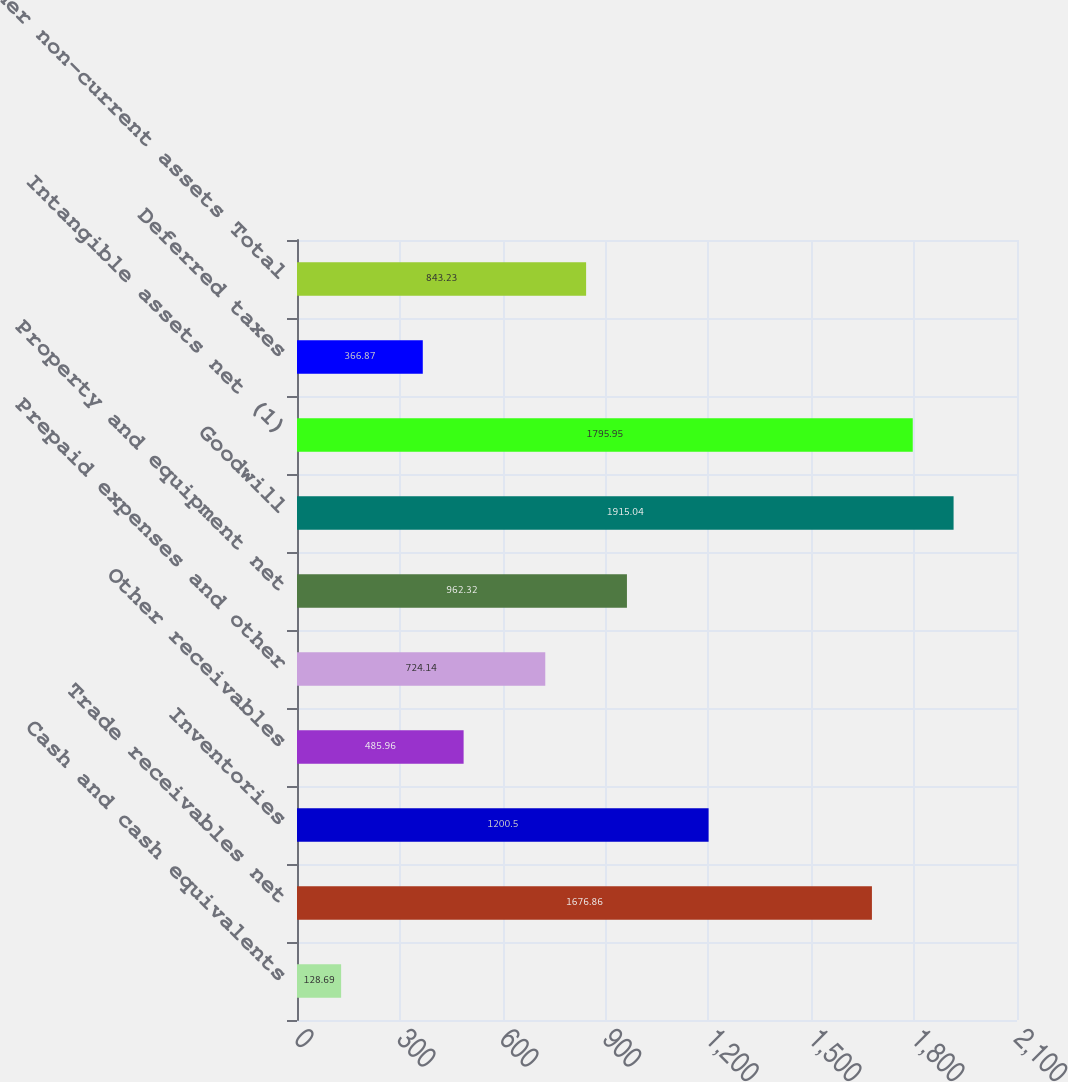<chart> <loc_0><loc_0><loc_500><loc_500><bar_chart><fcel>Cash and cash equivalents<fcel>Trade receivables net<fcel>Inventories<fcel>Other receivables<fcel>Prepaid expenses and other<fcel>Property and equipment net<fcel>Goodwill<fcel>Intangible assets net (1)<fcel>Deferred taxes<fcel>Other non-current assets Total<nl><fcel>128.69<fcel>1676.86<fcel>1200.5<fcel>485.96<fcel>724.14<fcel>962.32<fcel>1915.04<fcel>1795.95<fcel>366.87<fcel>843.23<nl></chart> 